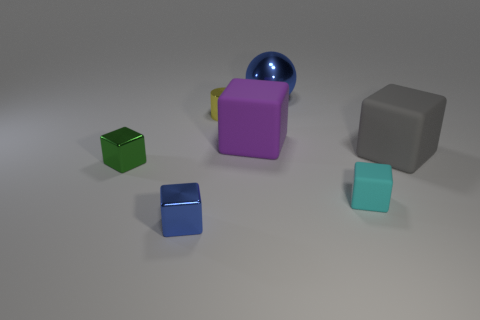Subtract all large purple cubes. How many cubes are left? 4 Subtract all blue cubes. How many cubes are left? 4 Add 1 tiny brown balls. How many objects exist? 8 Subtract all spheres. How many objects are left? 6 Subtract 1 cylinders. How many cylinders are left? 0 Subtract all green blocks. Subtract all brown cylinders. How many blocks are left? 4 Subtract all brown balls. How many cyan blocks are left? 1 Subtract all brown matte blocks. Subtract all big gray cubes. How many objects are left? 6 Add 1 shiny spheres. How many shiny spheres are left? 2 Add 1 big red rubber blocks. How many big red rubber blocks exist? 1 